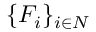Convert formula to latex. <formula><loc_0><loc_0><loc_500><loc_500>\{ { F } _ { i } \} _ { i \in N }</formula> 